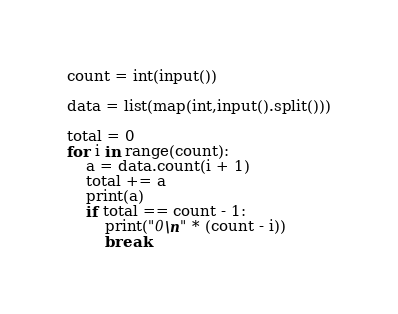Convert code to text. <code><loc_0><loc_0><loc_500><loc_500><_Python_>count = int(input())

data = list(map(int,input().split()))

total = 0
for i in range(count):
    a = data.count(i + 1)
    total += a
    print(a)
    if total == count - 1:
        print("0\n" * (count - i))
        break</code> 